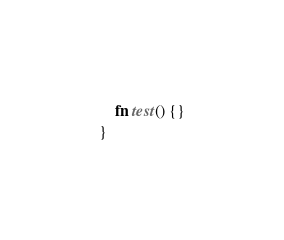Convert code to text. <code><loc_0><loc_0><loc_500><loc_500><_Rust_>    fn test() {}
}
</code> 